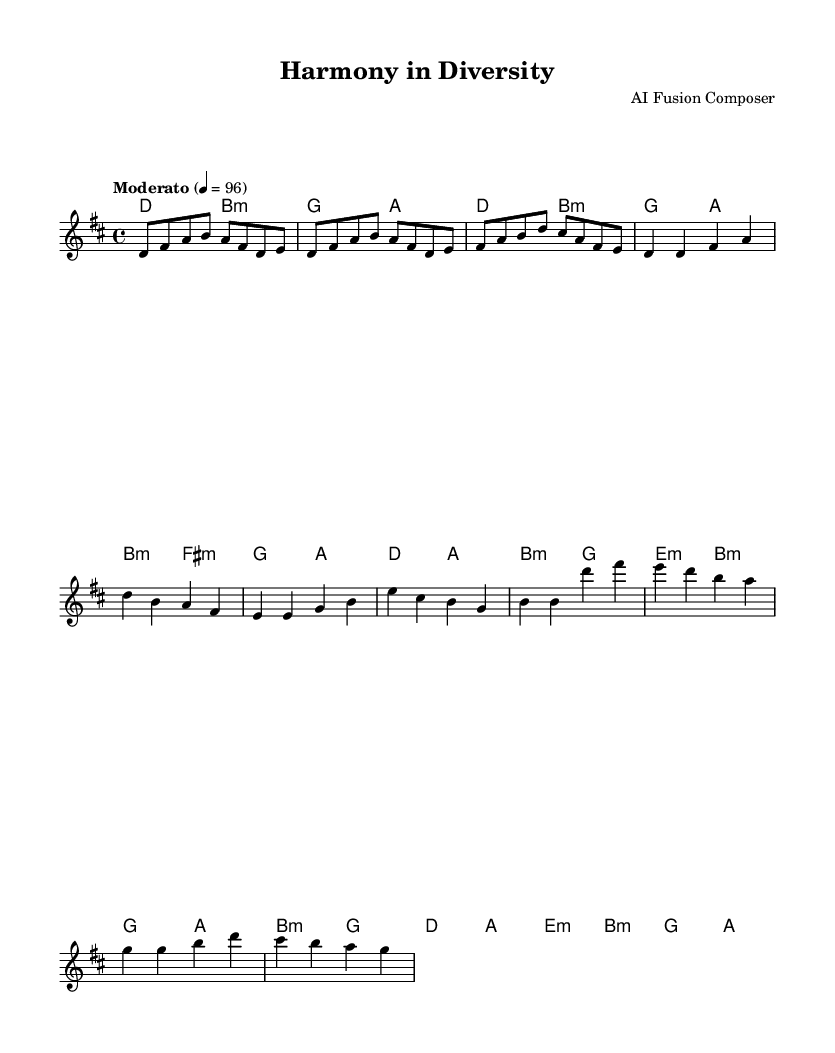What is the key signature of this music? The key signature indicated in the music is D major, which has two sharps (F# and C#). You can tell by looking at the signature at the beginning of the staff, which provides the necessary accidentals used throughout the piece.
Answer: D major What is the time signature of this music? The time signature in the music is 4/4, which means there are four beats per measure and the quarter note receives one beat. This is usually visible at the beginning of the music notation, indicating the rhythmic structure.
Answer: 4/4 What is the tempo marking of this music? The tempo marking shown in the music is "Moderato" at a speed of quarter note equals 96 beats per minute. This is usually found at the beginning of the score, specifically indicating the pace at which the piece should be played.
Answer: Moderato 4 = 96 How many measures are in the chorus section? The chorus section contains four measures, which can be counted by looking at the notation in that section. Each measure has vertical bar lines separating them, allowing a clear identification of how many complete measures are present in the chorus.
Answer: 4 Which chords are used in the bridge? The chords used in the bridge are B minor, G, D major, A, E minor, and B minor. By examining the chord progression related to the bridge section, we can identify the specific chords that appear within those measures.
Answer: B minor, G, D, A, E minor What is the primary cultural influence reflected in the music's fusion style? The primary cultural influence is a blending of acoustic elements with electronic sounds, representing the diverse backgrounds and emotional expressions in relationships. This can be inferred from the combination of the organic melody lines typically found in acoustic music and the structured, perhaps synthesized harmonies reflecting electronic music.
Answer: Acoustic-electronic fusion 